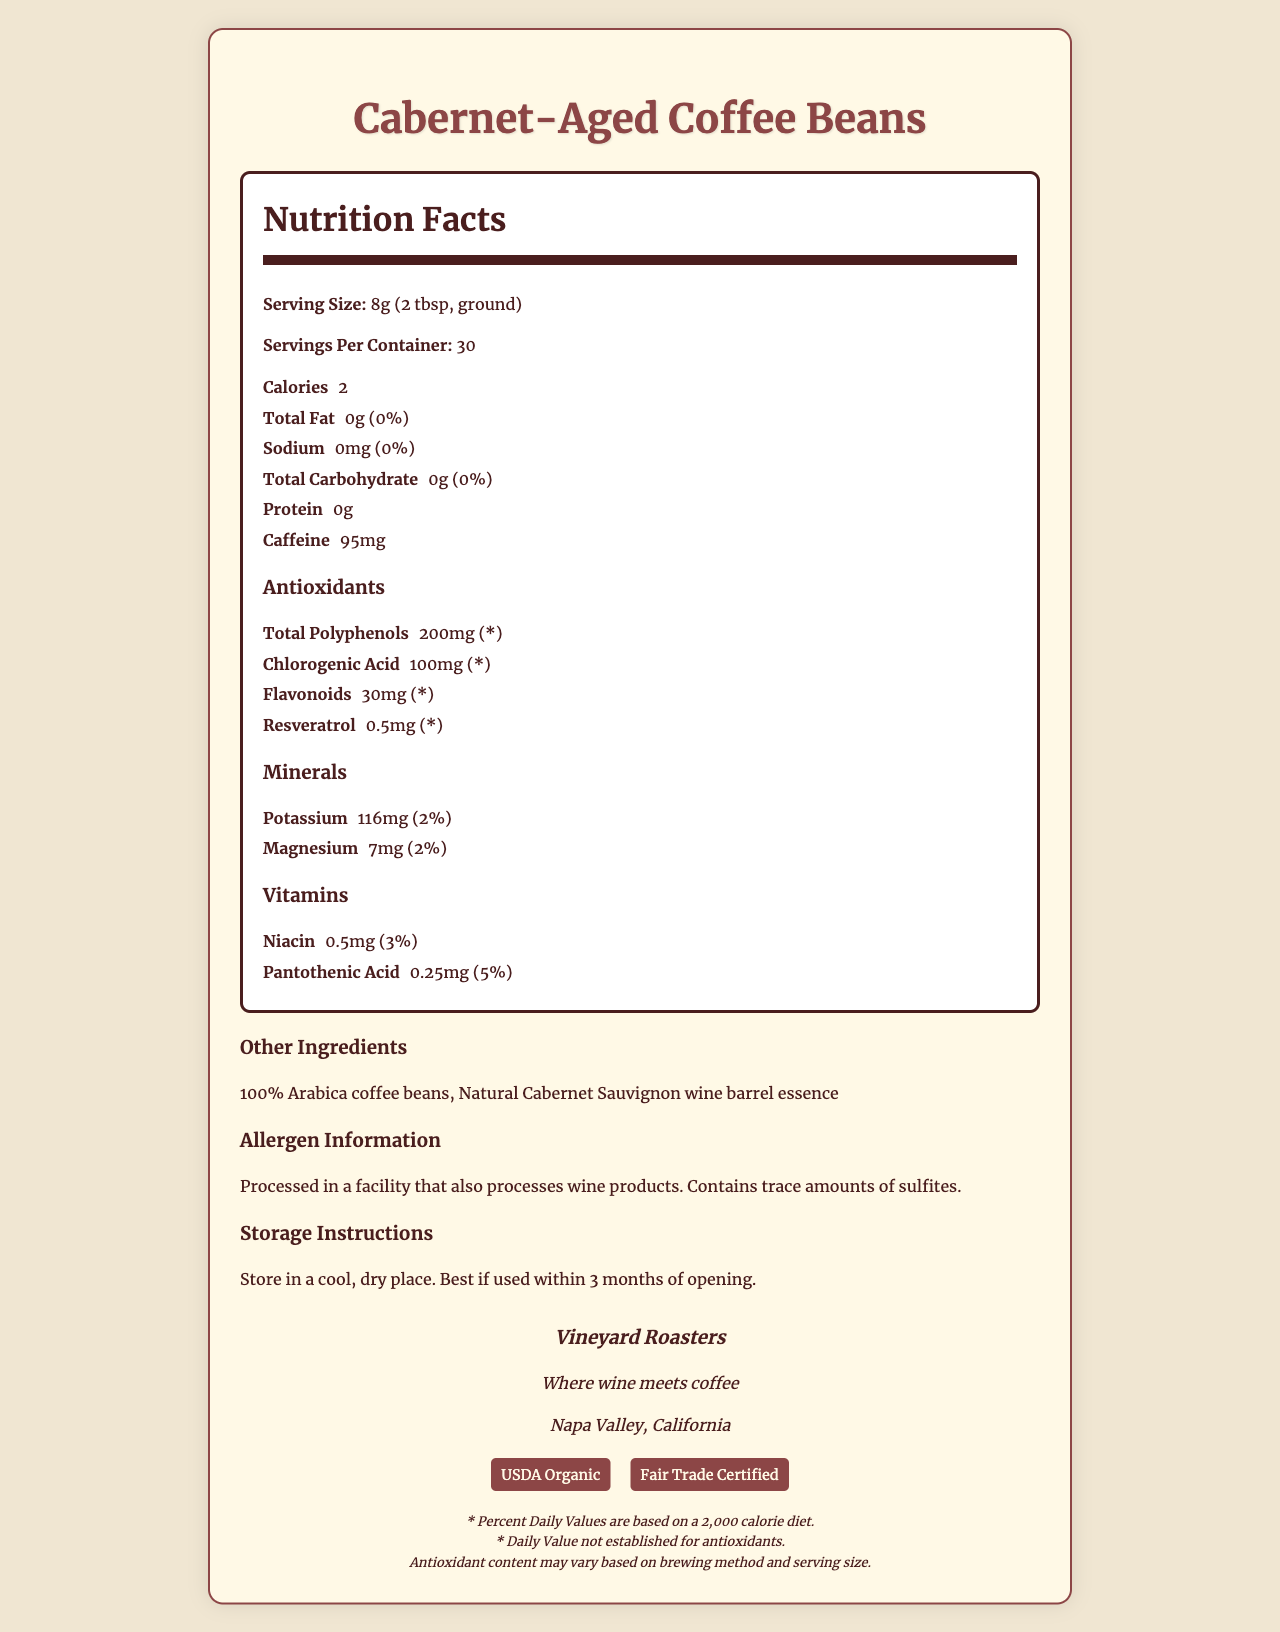What is the serving size for Cabernet-Aged Coffee Beans? The serving size is stated as "8g (2 tbsp, ground)" in the nutrition label.
Answer: 8g (2 tbsp, ground) How many servings per container are there? The label mentions that there are 30 servings per container.
Answer: 30 How many calories are in one serving of the coffee beans? The nutrition label indicates that one serving contains 2 calories.
Answer: 2 What is the amount of caffeine per serving? The label specifies that each serving contains 95mg of caffeine.
Answer: 95mg What are the total amounts of polyphenols per serving? The antioxidant section of the label lists total polyphenols as 200mg per serving.
Answer: 200mg Which brand produces Cabernet-Aged Coffee Beans? A. Napa Valley Roasters B. Vineyard Roasters C. Cabernet Coffee The brand is Vineyard Roasters, as indicated in the brand information section.
Answer: B What are the two main vitamins present in the coffee beans, along with their amounts? The vitamins section indicates the presence of Niacin (0.5mg) and Pantothenic Acid (0.25mg).
Answer: Niacin: 0.5mg, Pantothenic Acid: 0.25mg Which certifications does the product have? A. USDA Organic B. Fair Trade Certified C. Vegan Certified The certifications section lists USDA Organic and Fair Trade Certified.
Answer: A and B Does the coffee contain any allergens? The allergen information mentions that the coffee contains trace amounts of sulfites.
Answer: Yes Summarize the main idea of the document. The document is a comprehensive nutrition label for Cabernet-Aged Coffee Beans, presenting various nutritional details, ingredients, allergens, storage instructions, and certifications from the brand "Vineyard Roasters."
Answer: The document provides detailed nutrition facts for Cabernet-Aged Coffee Beans, including serving size, calories, fat, sodium, carbohydrates, protein, caffeine content, and a breakdown of antioxidants, minerals, and vitamins. It also includes information about other ingredients, allergen warnings, storage instructions, brand information, and certifications. Can this label be used to determine the antioxidant content per serving based on different brewing methods? The disclaimer mentions that antioxidant content may vary based on brewing method and serving size, indicating that the exact values could change and are not provided for different brewing methods.
Answer: Not enough information 